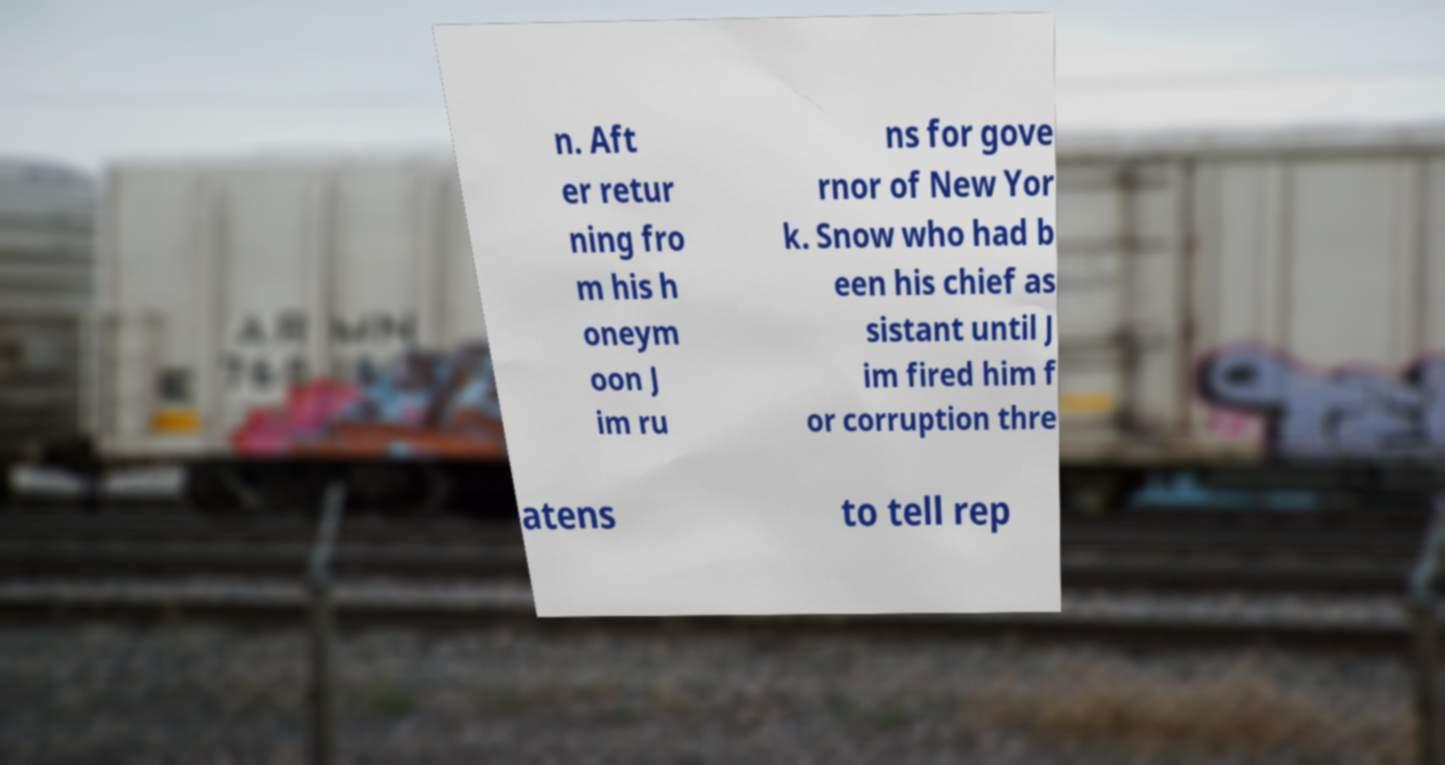Can you read and provide the text displayed in the image?This photo seems to have some interesting text. Can you extract and type it out for me? n. Aft er retur ning fro m his h oneym oon J im ru ns for gove rnor of New Yor k. Snow who had b een his chief as sistant until J im fired him f or corruption thre atens to tell rep 